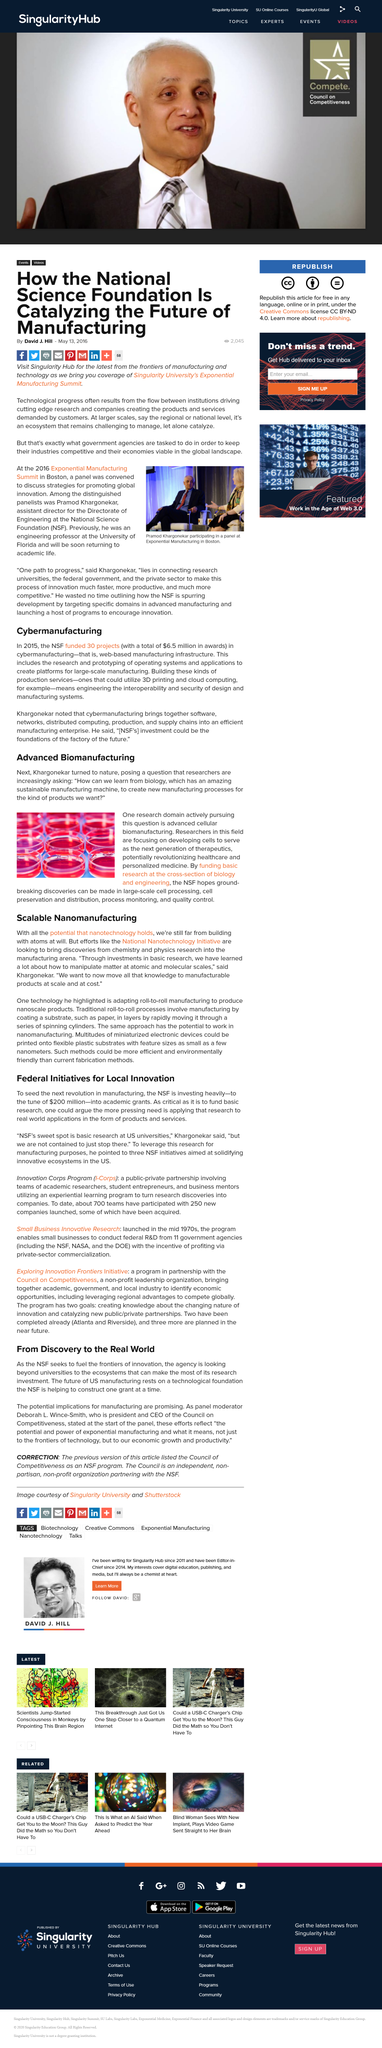Identify some key points in this picture. The image on the right was taken at the Exponential Manufacturing Summit. Researchers are in the process of developing cells as the next generation of therapeutics. The article "How the National Science Foundation is Catalyzing the Future of Manufacturing" was published on May 13, 2016, as stated in the article itself. Cybermanufacturing is a web-based manufacturing infrastructure that enables the integration and optimization of diverse technologies, processes, and business functions to enhance the design, engineering, and production of advanced manufacturing systems. We, at the National Science Foundation, aim to fuel the frontiers of innovation through our research and initiatives. 